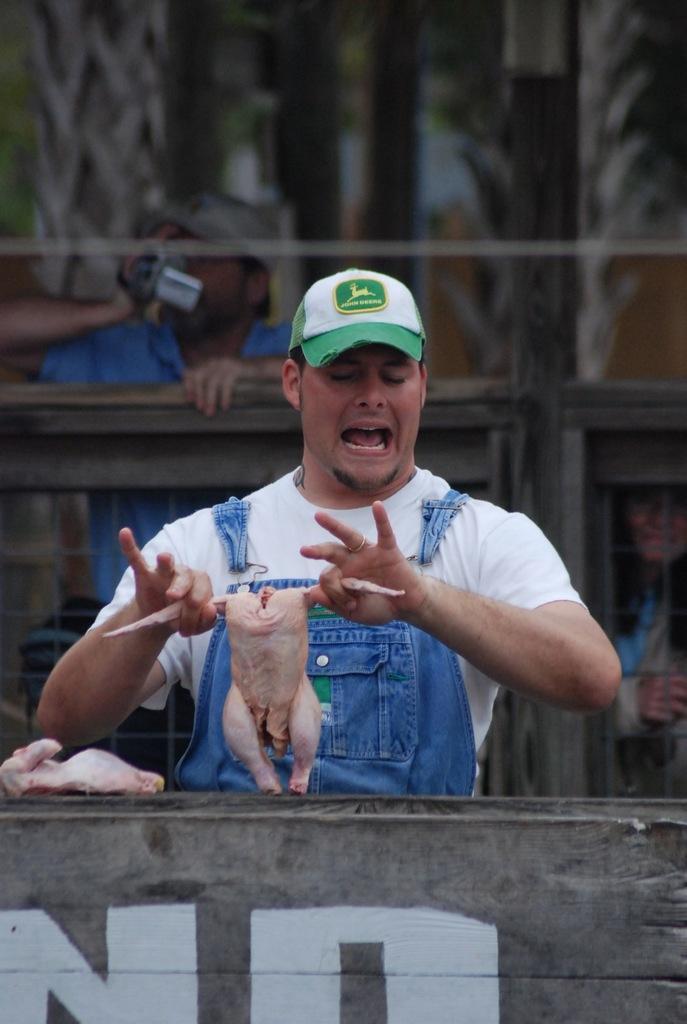In one or two sentences, can you explain what this image depicts? In the picture we can see a man standing near the table and holding a chicken with two hands and he is with white T-shirt and cap and on the table, we can see a slice of chicken and behind him we can see another person standing behind the railing, holding a camera and capturing something. 